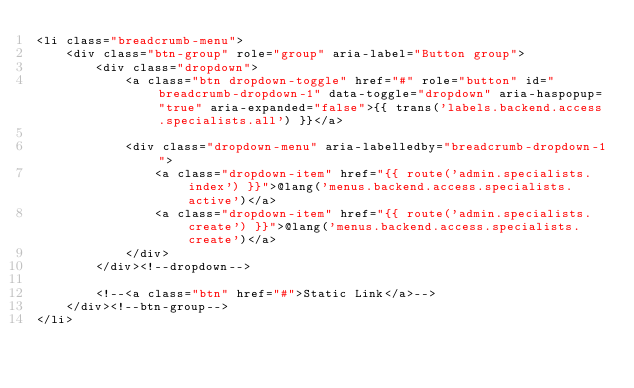<code> <loc_0><loc_0><loc_500><loc_500><_PHP_><li class="breadcrumb-menu">
    <div class="btn-group" role="group" aria-label="Button group">
        <div class="dropdown">
            <a class="btn dropdown-toggle" href="#" role="button" id="breadcrumb-dropdown-1" data-toggle="dropdown" aria-haspopup="true" aria-expanded="false">{{ trans('labels.backend.access.specialists.all') }}</a>

            <div class="dropdown-menu" aria-labelledby="breadcrumb-dropdown-1">
                <a class="dropdown-item" href="{{ route('admin.specialists.index') }}">@lang('menus.backend.access.specialists.active')</a>
                <a class="dropdown-item" href="{{ route('admin.specialists.create') }}">@lang('menus.backend.access.specialists.create')</a>
            </div>
        </div><!--dropdown-->

        <!--<a class="btn" href="#">Static Link</a>-->
    </div><!--btn-group-->
</li></code> 